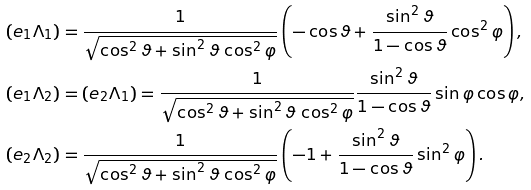Convert formula to latex. <formula><loc_0><loc_0><loc_500><loc_500>( e _ { 1 } \Lambda _ { 1 } ) & = \frac { 1 } { \sqrt { \cos ^ { 2 } \vartheta + \sin ^ { 2 } \vartheta \, \cos ^ { 2 } \varphi } } \left ( - \cos \vartheta + \frac { \sin ^ { 2 } \vartheta } { 1 - \cos \vartheta } \cos ^ { 2 } \varphi \right ) , \\ ( e _ { 1 } \Lambda _ { 2 } ) & = ( e _ { 2 } \Lambda _ { 1 } ) = \frac { 1 } { \sqrt { \cos ^ { 2 } \vartheta + \sin ^ { 2 } \vartheta \, \cos ^ { 2 } \varphi } } \frac { \sin ^ { 2 } \vartheta } { 1 - \cos \vartheta } \sin \varphi \cos \varphi , \\ ( e _ { 2 } \Lambda _ { 2 } ) & = \frac { 1 } { \sqrt { \cos ^ { 2 } \vartheta + \sin ^ { 2 } \vartheta \, \cos ^ { 2 } \varphi } } \left ( - 1 + \frac { \sin ^ { 2 } \vartheta } { 1 - \cos \vartheta } \sin ^ { 2 } \varphi \right ) .</formula> 